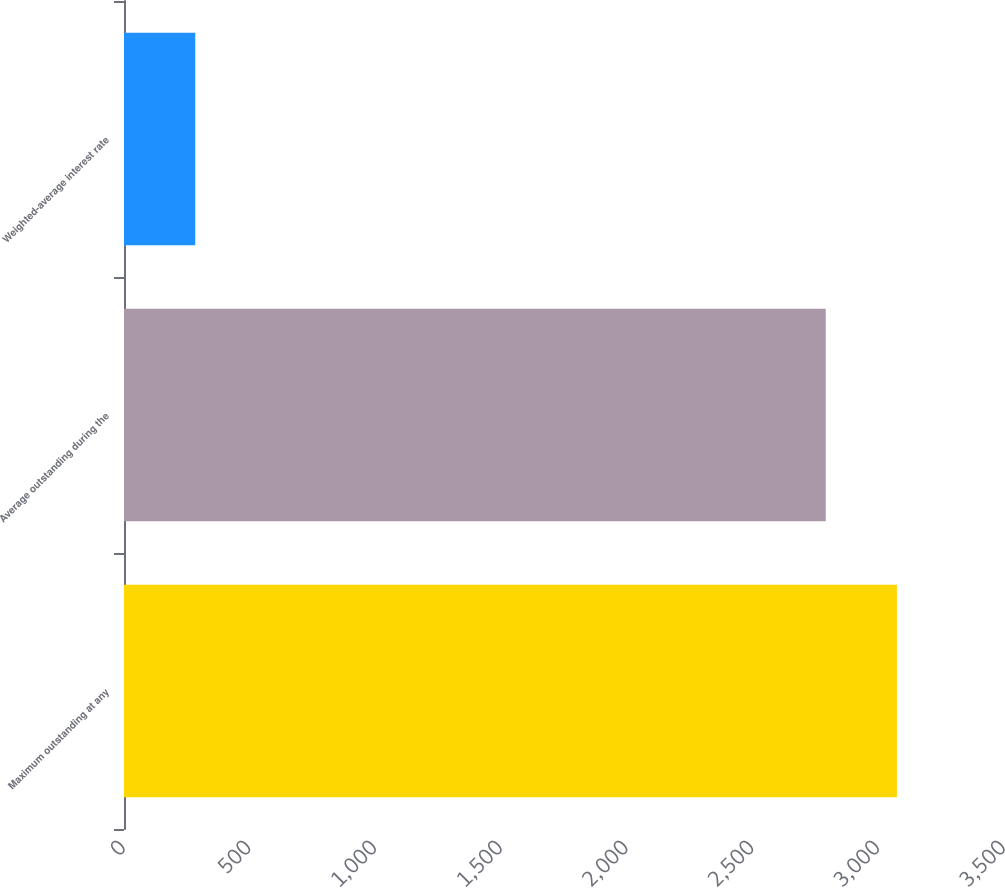<chart> <loc_0><loc_0><loc_500><loc_500><bar_chart><fcel>Maximum outstanding at any<fcel>Average outstanding during the<fcel>Weighted-average interest rate<nl><fcel>3074.07<fcel>2791<fcel>283.38<nl></chart> 